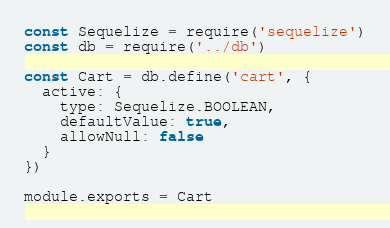Convert code to text. <code><loc_0><loc_0><loc_500><loc_500><_JavaScript_>const Sequelize = require('sequelize')
const db = require('../db')

const Cart = db.define('cart', {
  active: {
    type: Sequelize.BOOLEAN,
    defaultValue: true,
    allowNull: false
  }
})

module.exports = Cart
</code> 